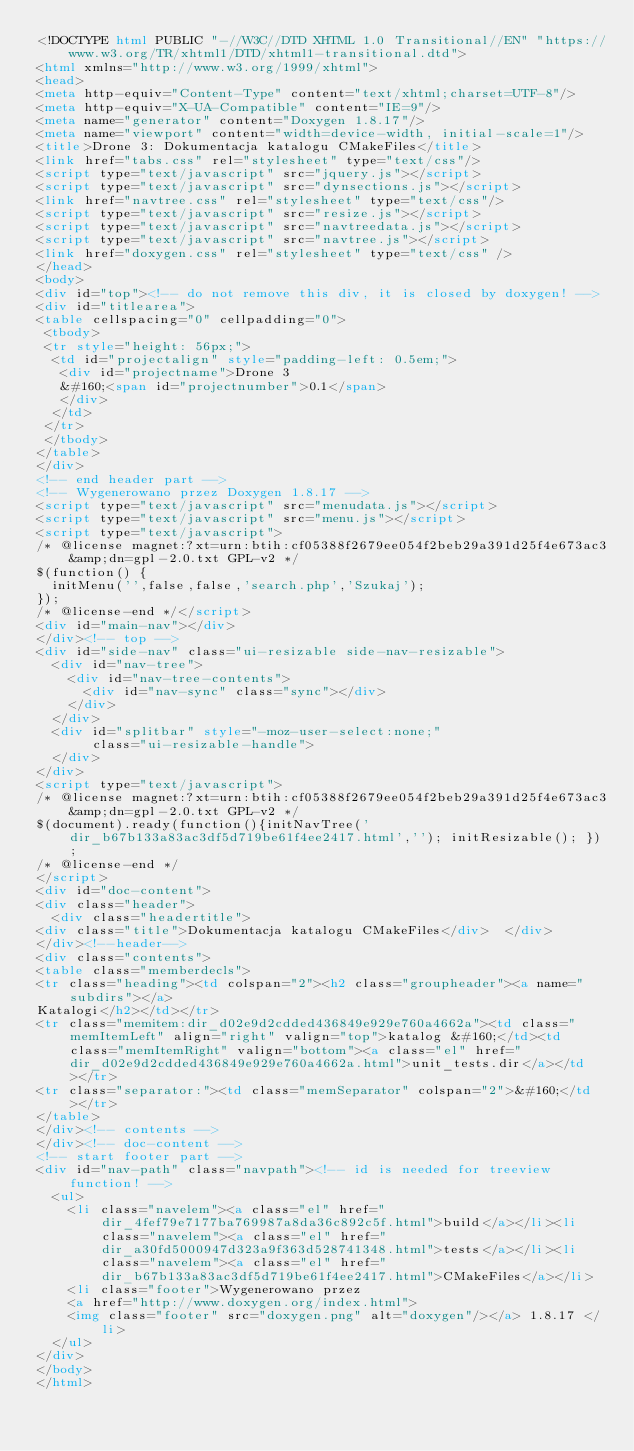<code> <loc_0><loc_0><loc_500><loc_500><_HTML_><!DOCTYPE html PUBLIC "-//W3C//DTD XHTML 1.0 Transitional//EN" "https://www.w3.org/TR/xhtml1/DTD/xhtml1-transitional.dtd">
<html xmlns="http://www.w3.org/1999/xhtml">
<head>
<meta http-equiv="Content-Type" content="text/xhtml;charset=UTF-8"/>
<meta http-equiv="X-UA-Compatible" content="IE=9"/>
<meta name="generator" content="Doxygen 1.8.17"/>
<meta name="viewport" content="width=device-width, initial-scale=1"/>
<title>Drone 3: Dokumentacja katalogu CMakeFiles</title>
<link href="tabs.css" rel="stylesheet" type="text/css"/>
<script type="text/javascript" src="jquery.js"></script>
<script type="text/javascript" src="dynsections.js"></script>
<link href="navtree.css" rel="stylesheet" type="text/css"/>
<script type="text/javascript" src="resize.js"></script>
<script type="text/javascript" src="navtreedata.js"></script>
<script type="text/javascript" src="navtree.js"></script>
<link href="doxygen.css" rel="stylesheet" type="text/css" />
</head>
<body>
<div id="top"><!-- do not remove this div, it is closed by doxygen! -->
<div id="titlearea">
<table cellspacing="0" cellpadding="0">
 <tbody>
 <tr style="height: 56px;">
  <td id="projectalign" style="padding-left: 0.5em;">
   <div id="projectname">Drone 3
   &#160;<span id="projectnumber">0.1</span>
   </div>
  </td>
 </tr>
 </tbody>
</table>
</div>
<!-- end header part -->
<!-- Wygenerowano przez Doxygen 1.8.17 -->
<script type="text/javascript" src="menudata.js"></script>
<script type="text/javascript" src="menu.js"></script>
<script type="text/javascript">
/* @license magnet:?xt=urn:btih:cf05388f2679ee054f2beb29a391d25f4e673ac3&amp;dn=gpl-2.0.txt GPL-v2 */
$(function() {
  initMenu('',false,false,'search.php','Szukaj');
});
/* @license-end */</script>
<div id="main-nav"></div>
</div><!-- top -->
<div id="side-nav" class="ui-resizable side-nav-resizable">
  <div id="nav-tree">
    <div id="nav-tree-contents">
      <div id="nav-sync" class="sync"></div>
    </div>
  </div>
  <div id="splitbar" style="-moz-user-select:none;" 
       class="ui-resizable-handle">
  </div>
</div>
<script type="text/javascript">
/* @license magnet:?xt=urn:btih:cf05388f2679ee054f2beb29a391d25f4e673ac3&amp;dn=gpl-2.0.txt GPL-v2 */
$(document).ready(function(){initNavTree('dir_b67b133a83ac3df5d719be61f4ee2417.html',''); initResizable(); });
/* @license-end */
</script>
<div id="doc-content">
<div class="header">
  <div class="headertitle">
<div class="title">Dokumentacja katalogu CMakeFiles</div>  </div>
</div><!--header-->
<div class="contents">
<table class="memberdecls">
<tr class="heading"><td colspan="2"><h2 class="groupheader"><a name="subdirs"></a>
Katalogi</h2></td></tr>
<tr class="memitem:dir_d02e9d2cdded436849e929e760a4662a"><td class="memItemLeft" align="right" valign="top">katalog &#160;</td><td class="memItemRight" valign="bottom"><a class="el" href="dir_d02e9d2cdded436849e929e760a4662a.html">unit_tests.dir</a></td></tr>
<tr class="separator:"><td class="memSeparator" colspan="2">&#160;</td></tr>
</table>
</div><!-- contents -->
</div><!-- doc-content -->
<!-- start footer part -->
<div id="nav-path" class="navpath"><!-- id is needed for treeview function! -->
  <ul>
    <li class="navelem"><a class="el" href="dir_4fef79e7177ba769987a8da36c892c5f.html">build</a></li><li class="navelem"><a class="el" href="dir_a30fd5000947d323a9f363d528741348.html">tests</a></li><li class="navelem"><a class="el" href="dir_b67b133a83ac3df5d719be61f4ee2417.html">CMakeFiles</a></li>
    <li class="footer">Wygenerowano przez
    <a href="http://www.doxygen.org/index.html">
    <img class="footer" src="doxygen.png" alt="doxygen"/></a> 1.8.17 </li>
  </ul>
</div>
</body>
</html>
</code> 